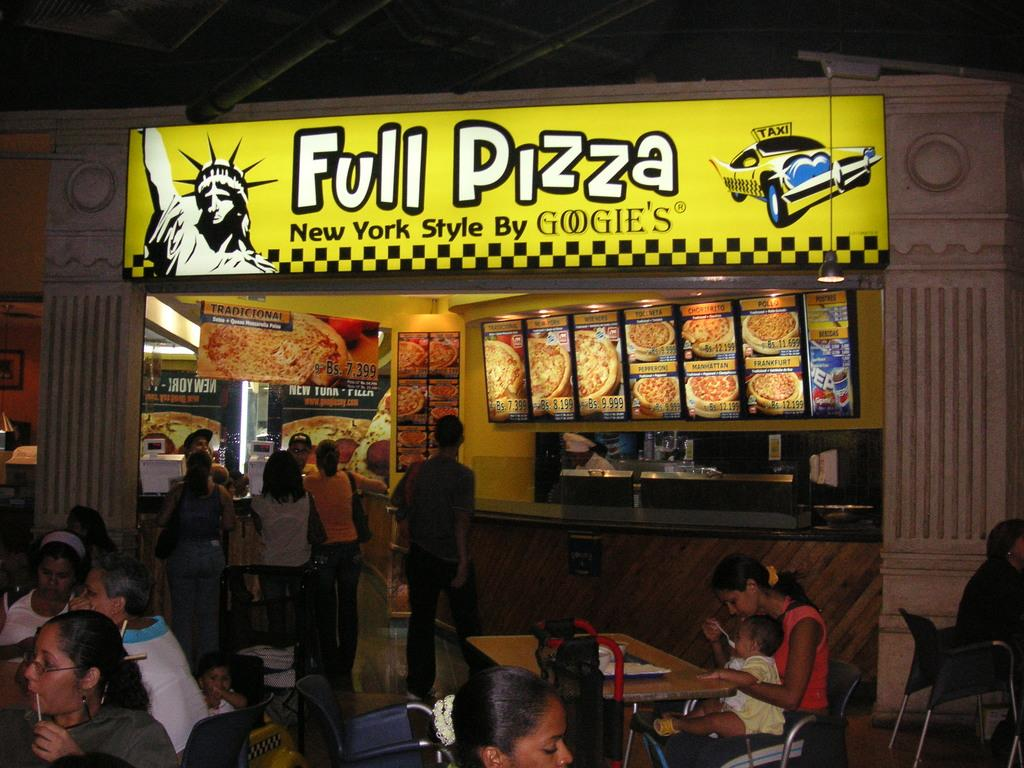How many people are in the image? There are people in the image, but the exact number is not specified. What are the people in the image doing? Some people are standing, while others are sitting, and they are having a meal. What can be seen on the wall in the image? There are food pictures on the wall. Is there any signage or identification in the image? Yes, there is a name board in the image. What type of control panel can be seen on the table in the image? There is no control panel present on the table in the image. Who is the representative of the group in the image? The image does not depict a specific representative for the group. 